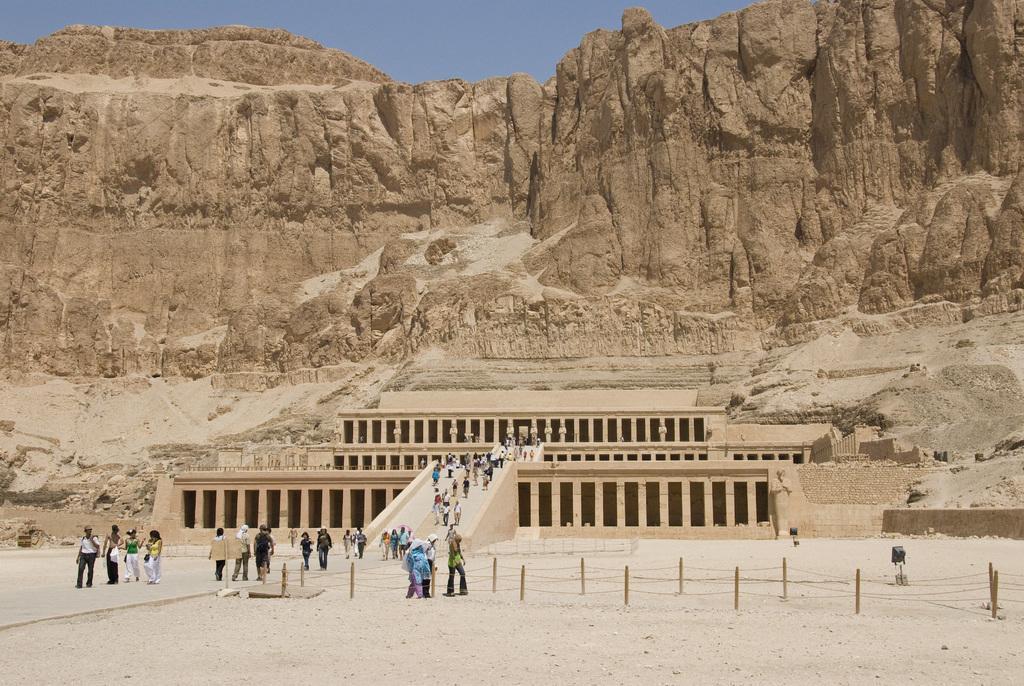Could you give a brief overview of what you see in this image? In the image there are many people walking on the path to a building engraved on a mountain and above its sky. 